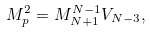Convert formula to latex. <formula><loc_0><loc_0><loc_500><loc_500>M _ { p } ^ { 2 } = M _ { N + 1 } ^ { N - 1 } V _ { N - 3 } ,</formula> 